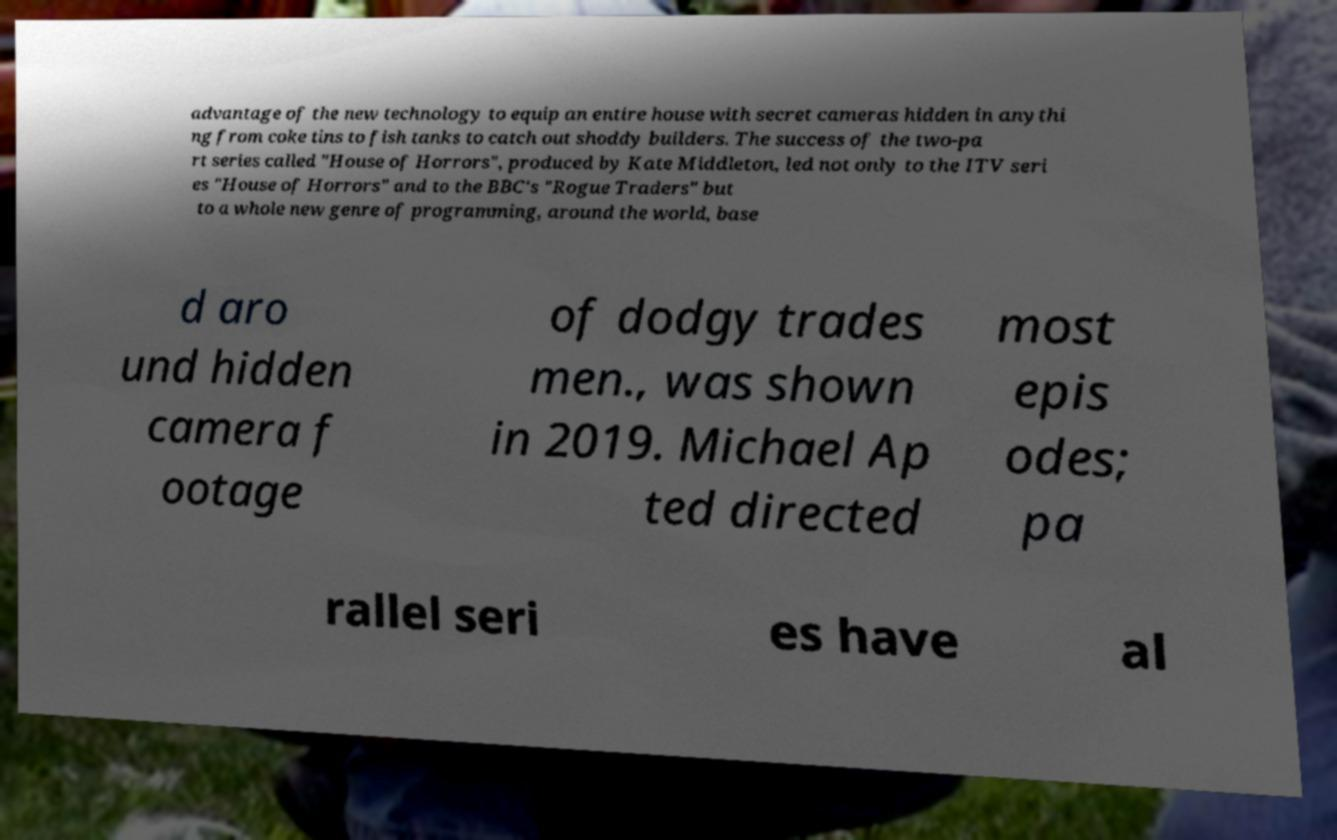Could you extract and type out the text from this image? advantage of the new technology to equip an entire house with secret cameras hidden in anythi ng from coke tins to fish tanks to catch out shoddy builders. The success of the two-pa rt series called "House of Horrors", produced by Kate Middleton, led not only to the ITV seri es "House of Horrors" and to the BBC's "Rogue Traders" but to a whole new genre of programming, around the world, base d aro und hidden camera f ootage of dodgy trades men., was shown in 2019. Michael Ap ted directed most epis odes; pa rallel seri es have al 